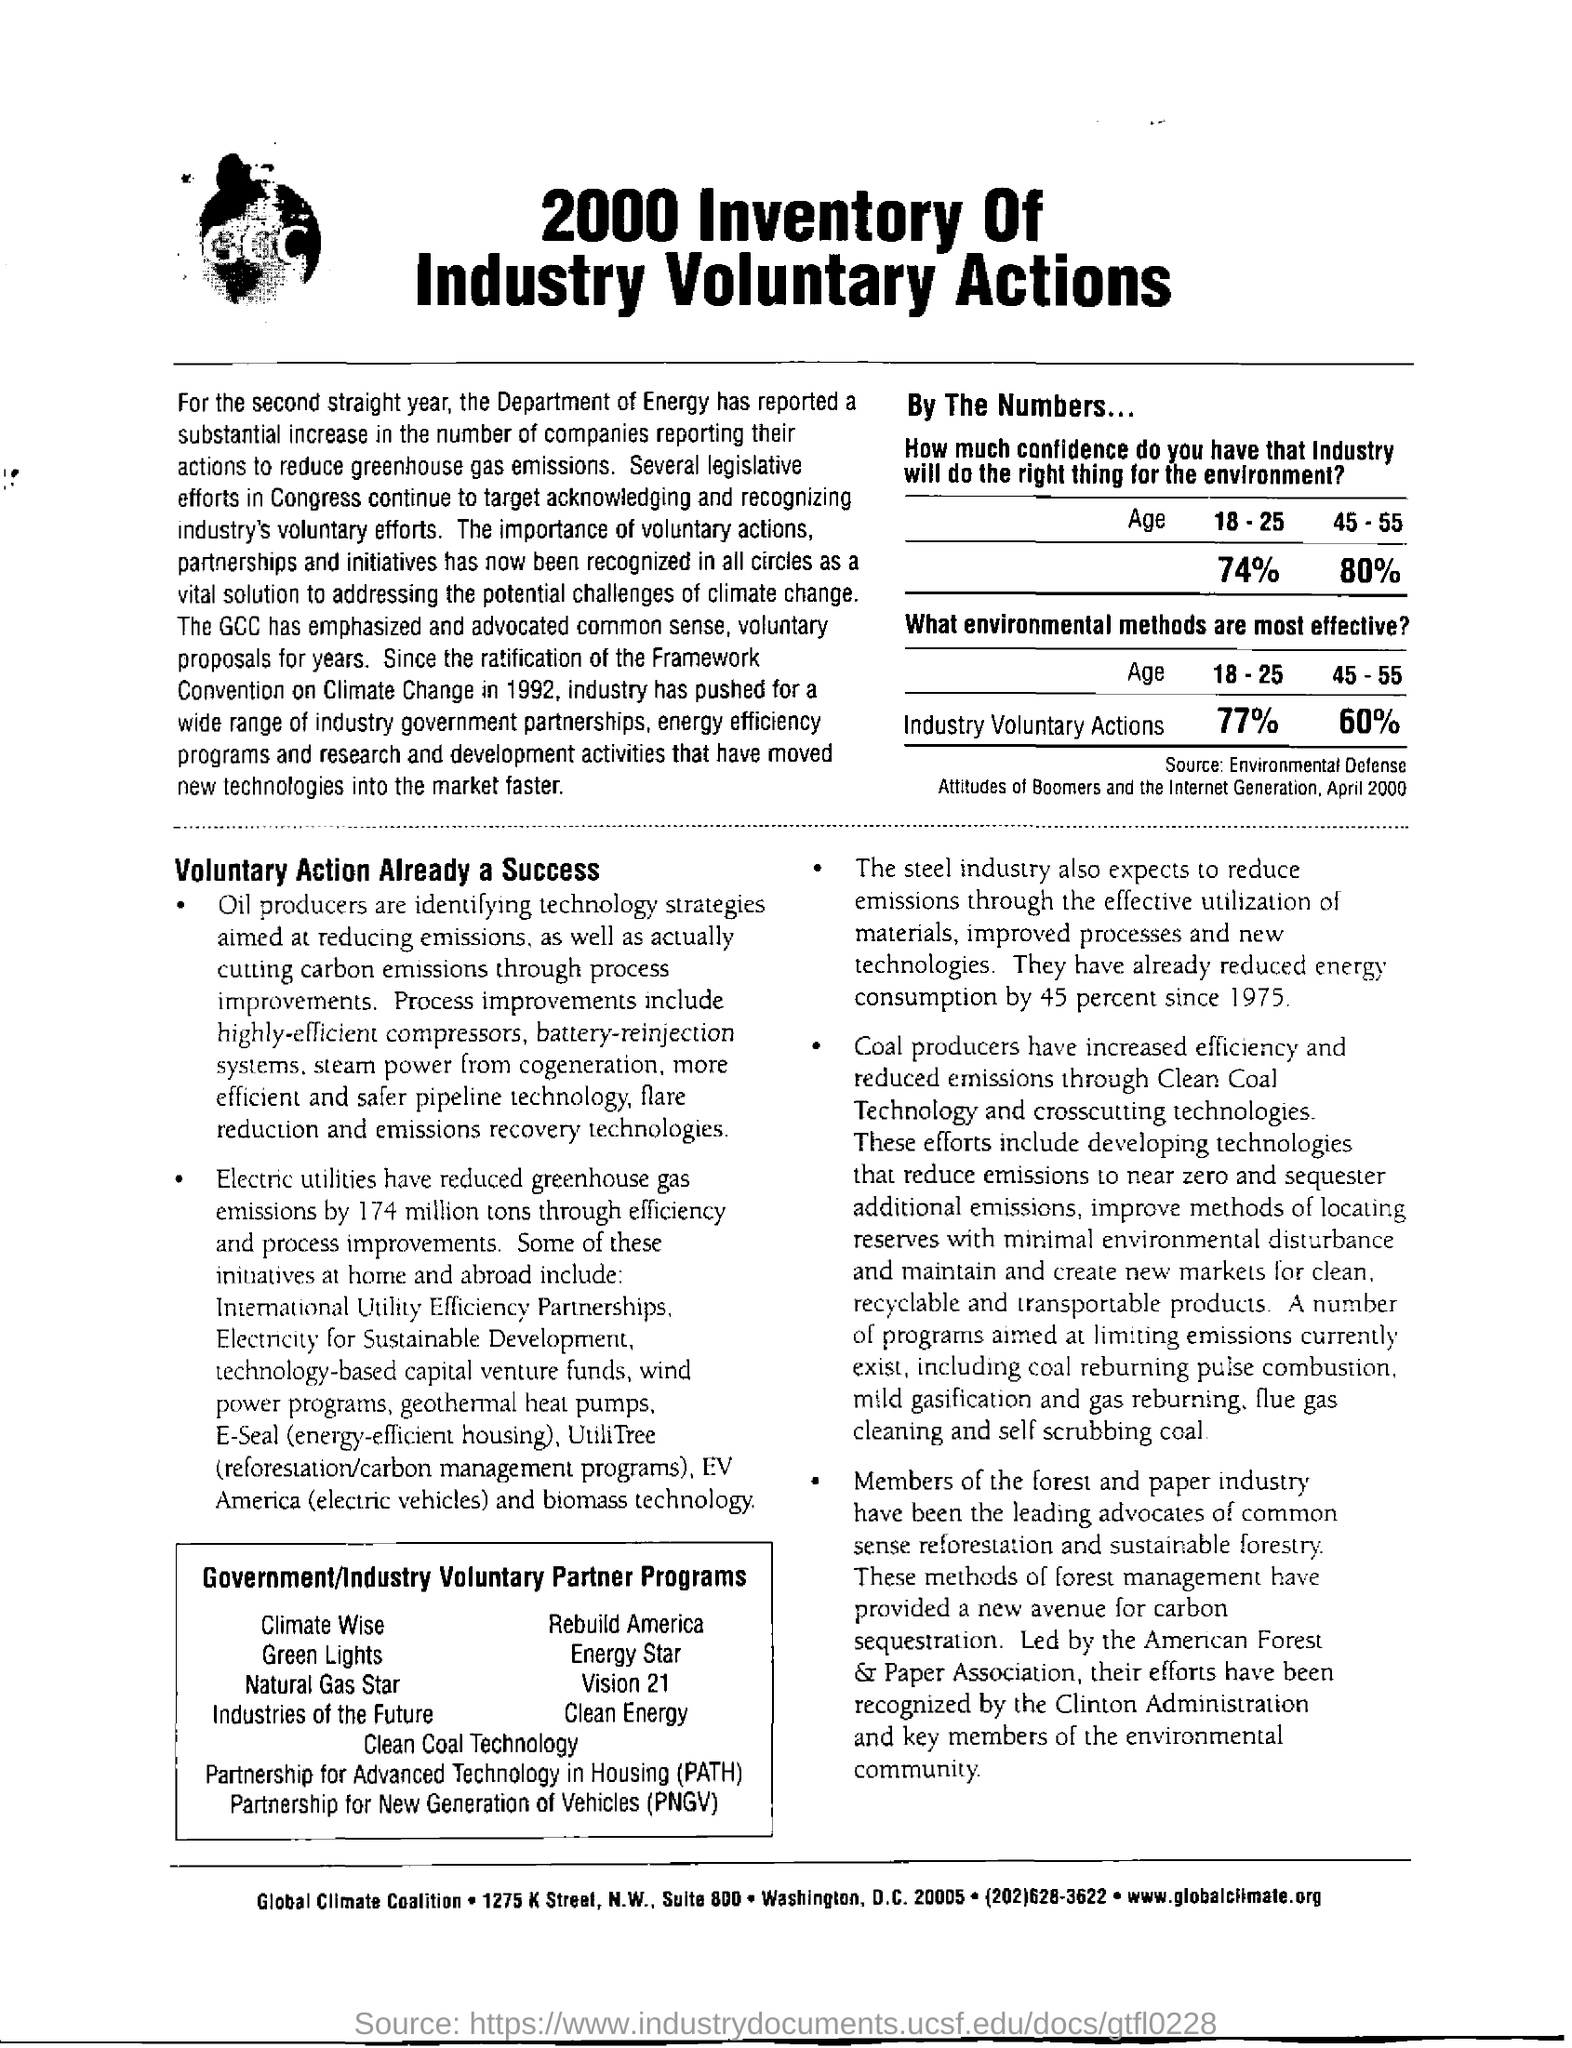Point out several critical features in this image. The full form of PNGV is Partnership for New Generation of Vehicles. This partnership is a collaborative effort between various organizations to develop and promote the use of new generation vehicles. Electric utilities have significantly reduced greenhouse emissions by 174 million tons. The source of the table provided is the "Environmental Defense Attitudes of Boomers and the Internet Generation, April 2000. PATH stands for Partnership for Advanced Technology in Housing. The steel industry has reduced its energy consumption by 45 percent since 1975. 